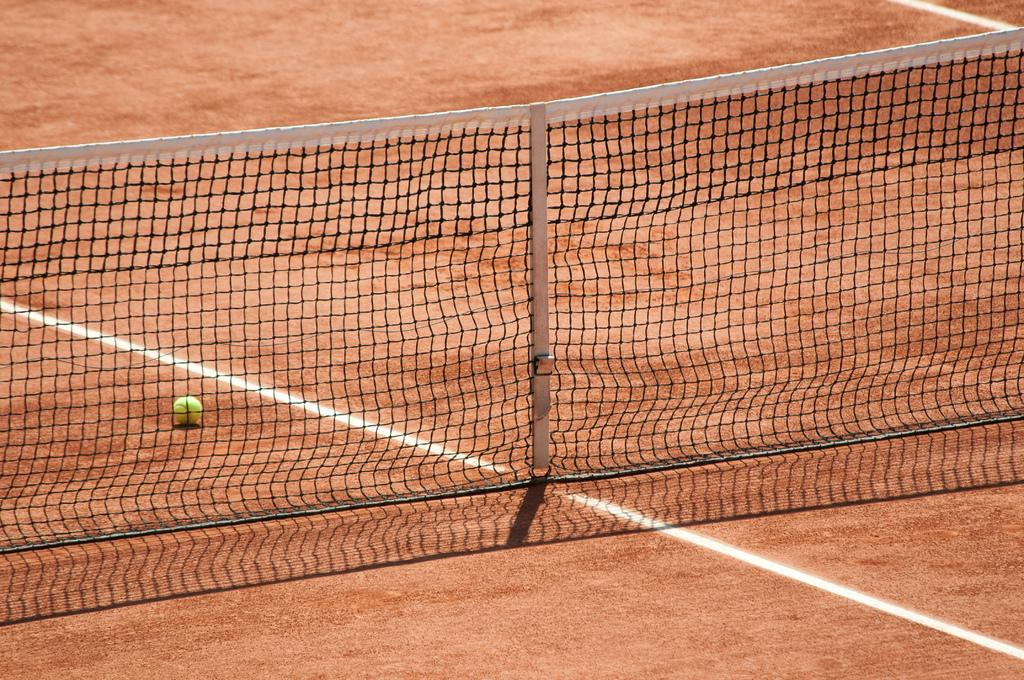What sport-related object is present in the image? There is a netball in the image. What type of surface is visible in the image? There is a ground visible in the image. What type of chalk is being used to draw on the netball in the image? There is no chalk or drawing on the netball in the image. What color is the sweater worn by the person holding the netball in the image? There is no person or sweater visible in the image; only the netball and ground are present. 